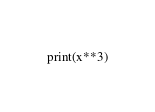<code> <loc_0><loc_0><loc_500><loc_500><_Python_>print(x**3)
</code> 